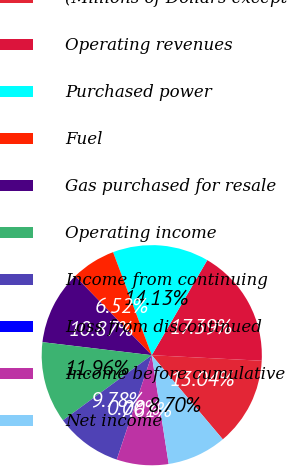<chart> <loc_0><loc_0><loc_500><loc_500><pie_chart><fcel>(Millions of Dollars except<fcel>Operating revenues<fcel>Purchased power<fcel>Fuel<fcel>Gas purchased for resale<fcel>Operating income<fcel>Income from continuing<fcel>Loss from discontinued<fcel>Income before cumulative<fcel>Net income<nl><fcel>13.04%<fcel>17.39%<fcel>14.13%<fcel>6.52%<fcel>10.87%<fcel>11.96%<fcel>9.78%<fcel>0.0%<fcel>7.61%<fcel>8.7%<nl></chart> 